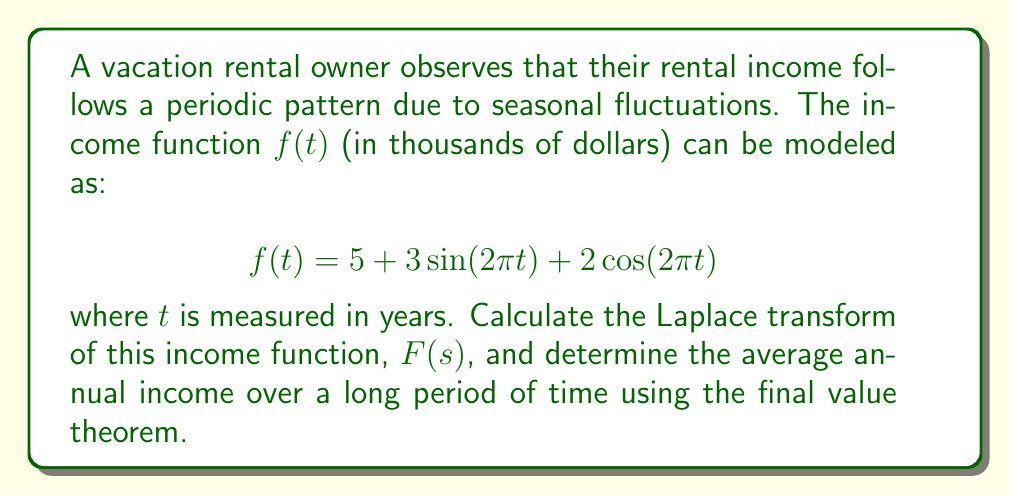Could you help me with this problem? To solve this problem, we'll follow these steps:

1) First, let's recall the Laplace transform of sine and cosine functions:
   
   $\mathcal{L}\{\sin(at)\} = \frac{a}{s^2 + a^2}$
   
   $\mathcal{L}\{\cos(at)\} = \frac{s}{s^2 + a^2}$

2) We also know that the Laplace transform is linear, meaning:
   
   $\mathcal{L}\{af(t) + bg(t)\} = a\mathcal{L}\{f(t)\} + b\mathcal{L}\{g(t)\}$

3) Now, let's break down our function and apply the Laplace transform:

   $f(t) = 5 + 3\sin(2\pi t) + 2\cos(2\pi t)$
   
   $F(s) = \mathcal{L}\{5\} + 3\mathcal{L}\{\sin(2\pi t)\} + 2\mathcal{L}\{\cos(2\pi t)\}$

4) Apply the Laplace transform rules:

   $F(s) = \frac{5}{s} + 3\cdot\frac{2\pi}{s^2 + (2\pi)^2} + 2\cdot\frac{s}{s^2 + (2\pi)^2}$

5) Simplify:

   $F(s) = \frac{5}{s} + \frac{6\pi}{s^2 + 4\pi^2} + \frac{2s}{s^2 + 4\pi^2}$

6) To find the average annual income over a long period, we can use the final value theorem:

   $\lim_{t \to \infty} f(t) = \lim_{s \to 0} sF(s)$

7) Apply this to our $F(s)$:

   $\lim_{s \to 0} s(\frac{5}{s} + \frac{6\pi}{s^2 + 4\pi^2} + \frac{2s}{s^2 + 4\pi^2})$

8) As $s$ approaches 0, the second and third terms approach 0, leaving us with:

   $\lim_{s \to 0} s(\frac{5}{s}) = 5$

Therefore, the average annual income over a long period is $5,000.
Answer: The Laplace transform of the income function is:

$$F(s) = \frac{5}{s} + \frac{6\pi}{s^2 + 4\pi^2} + \frac{2s}{s^2 + 4\pi^2}$$

The average annual income over a long period of time is $5,000. 